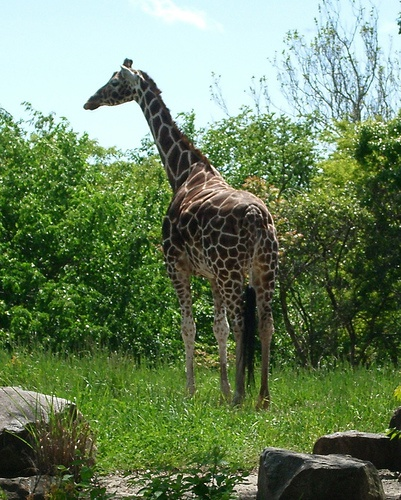Describe the objects in this image and their specific colors. I can see a giraffe in lightblue, black, gray, and darkgreen tones in this image. 